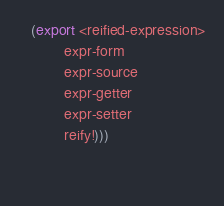Convert code to text. <code><loc_0><loc_0><loc_500><loc_500><_Scheme_>   (export <reified-expression>
           expr-form
           expr-source
           expr-getter
           expr-setter
           reify!)))

  
</code> 